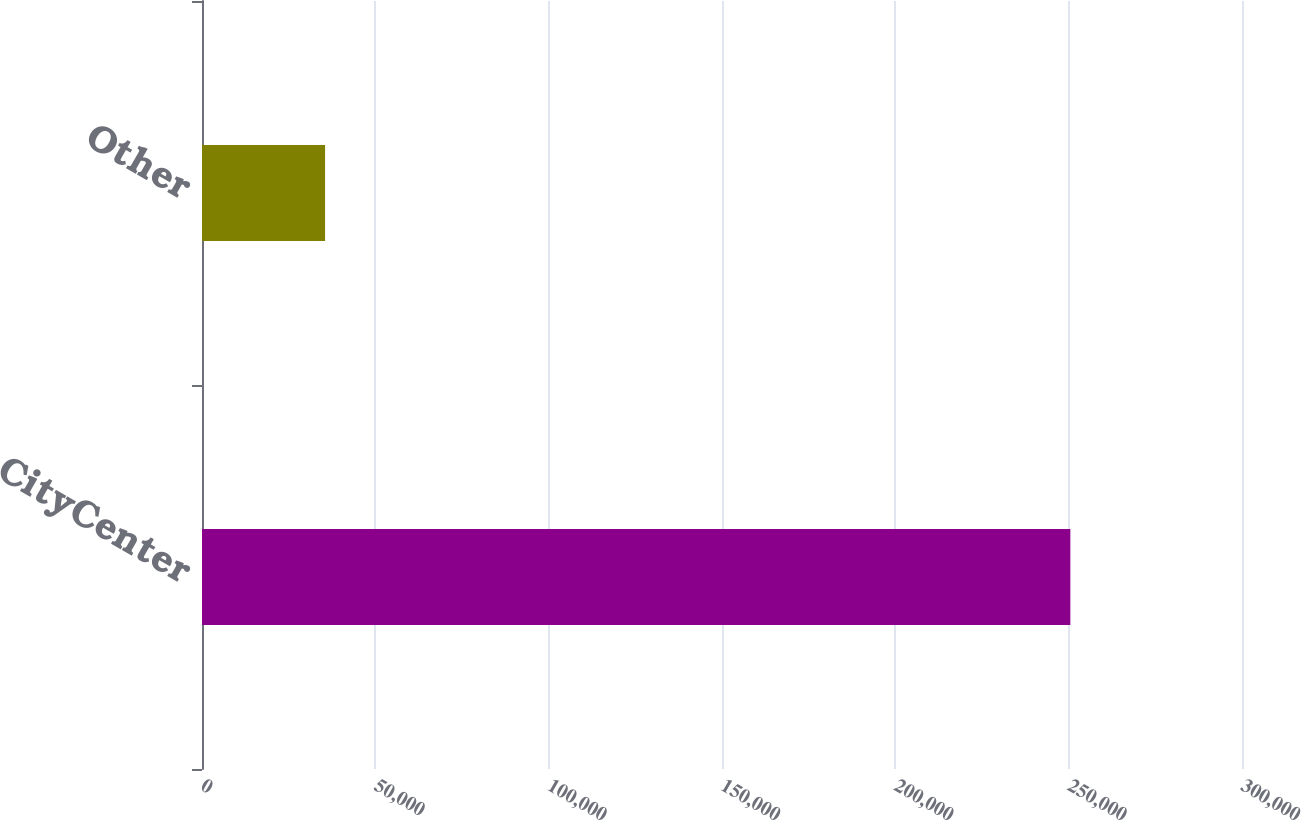<chart> <loc_0><loc_0><loc_500><loc_500><bar_chart><fcel>CityCenter<fcel>Other<nl><fcel>250482<fcel>35502<nl></chart> 